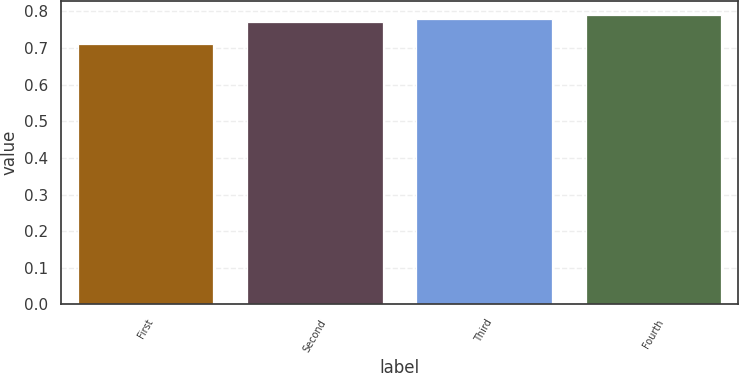Convert chart. <chart><loc_0><loc_0><loc_500><loc_500><bar_chart><fcel>First<fcel>Second<fcel>Third<fcel>Fourth<nl><fcel>0.71<fcel>0.77<fcel>0.78<fcel>0.79<nl></chart> 